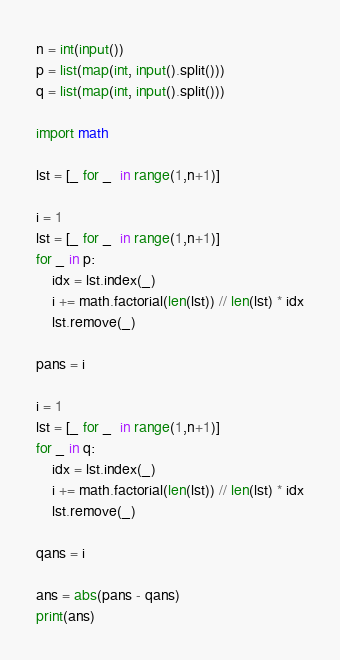Convert code to text. <code><loc_0><loc_0><loc_500><loc_500><_Python_>n = int(input())
p = list(map(int, input().split()))
q = list(map(int, input().split()))

import math

lst = [_ for _  in range(1,n+1)]

i = 1
lst = [_ for _  in range(1,n+1)]
for _ in p:
    idx = lst.index(_)
    i += math.factorial(len(lst)) // len(lst) * idx
    lst.remove(_)

pans = i

i = 1
lst = [_ for _  in range(1,n+1)]
for _ in q:
    idx = lst.index(_)
    i += math.factorial(len(lst)) // len(lst) * idx
    lst.remove(_)

qans = i

ans = abs(pans - qans)
print(ans)</code> 